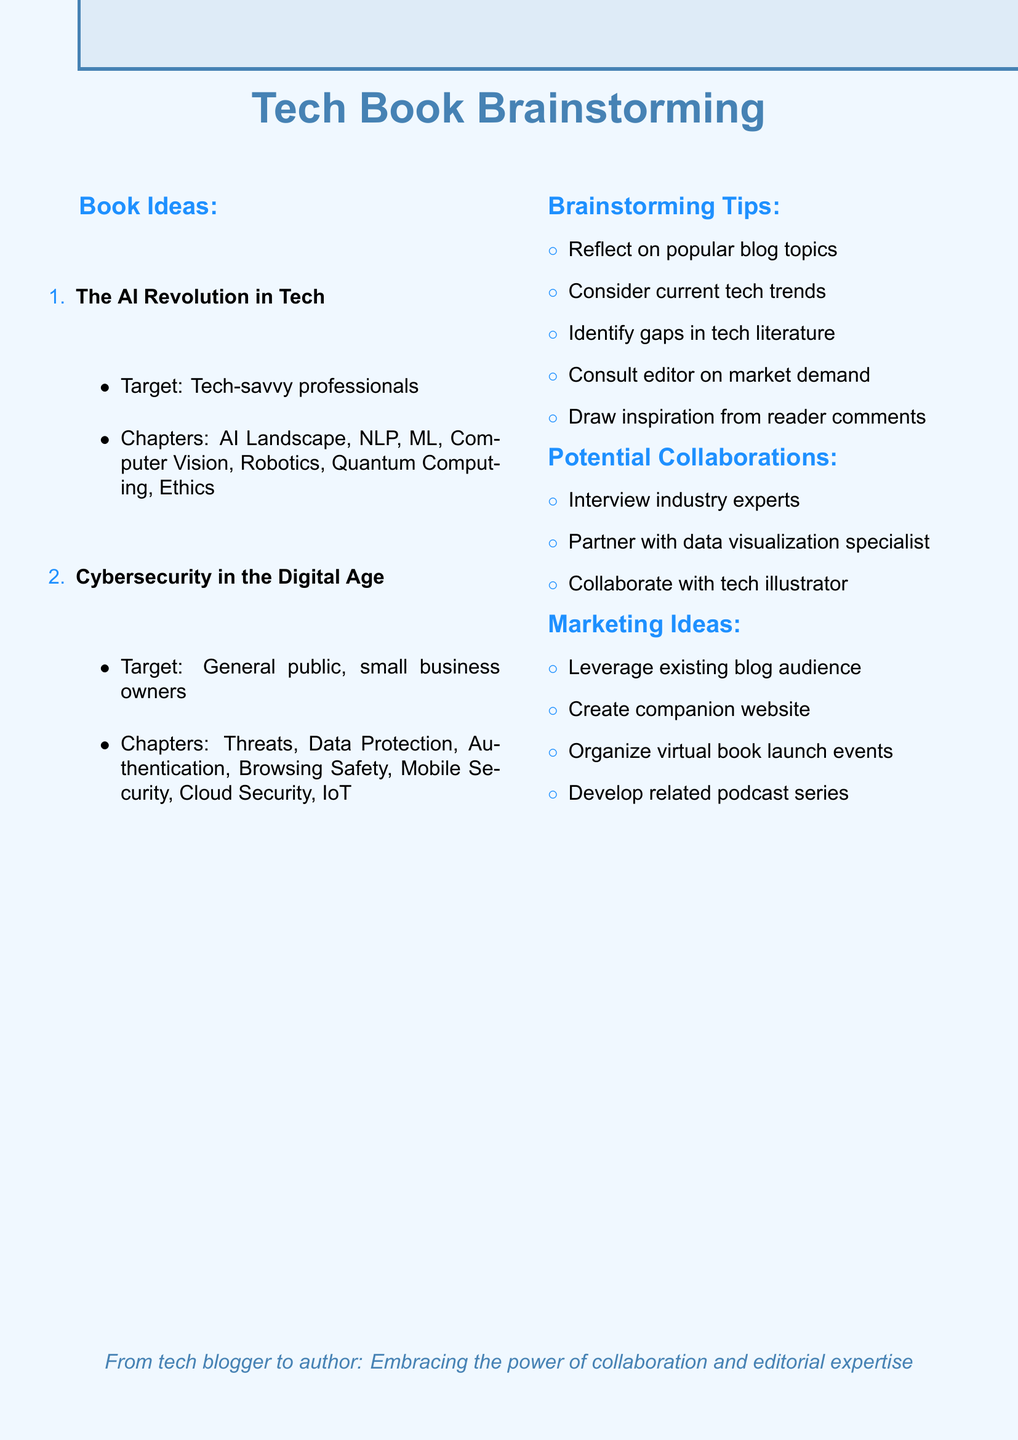What is the title of the first book idea? The title is the first line of the book ideas section, which states "The AI Revolution in Tech: From Chatbots to Quantum Computing."
Answer: The AI Revolution in Tech: From Chatbots to Quantum Computing Who is the target audience for the book on cybersecurity? The target audience is specified in the second book idea, mentioning "General public and small business owners concerned about online security."
Answer: General public and small business owners concerned about online security How many chapters are outlined for the AI book? The chapter outline for "The AI Revolution in Tech" consists of eight chapters, as listed in the document.
Answer: 8 What is one of the tips for brainstorming? The tips provided for brainstorming include several suggestions, one of which is "Reflect on popular topics from your tech blog that garnered significant reader engagement."
Answer: Reflect on popular topics from your tech blog that garnered significant reader engagement What collaboration is suggested involving a specialist? The document lists potential collaborations, one suggesting to "Partner with a data visualization specialist to create compelling infographics."
Answer: Partner with a data visualization specialist to create compelling infographics What is one marketing idea for the book? Among the marketing ideas, one suggestion is to "Leverage your existing blog audience through teasers and exclusive content."
Answer: Leverage your existing blog audience through teasers and exclusive content How many books are outlined in the document? There are two book ideas listed in the document, which is clear from the "Book Ideas" section.
Answer: 2 What is the purpose of the brainstorming session highlighted in the document? The purpose is indicated by the overall theme of generating and refining ideas for new tech books based on various factors.
Answer: Generating and refining ideas for new tech books 